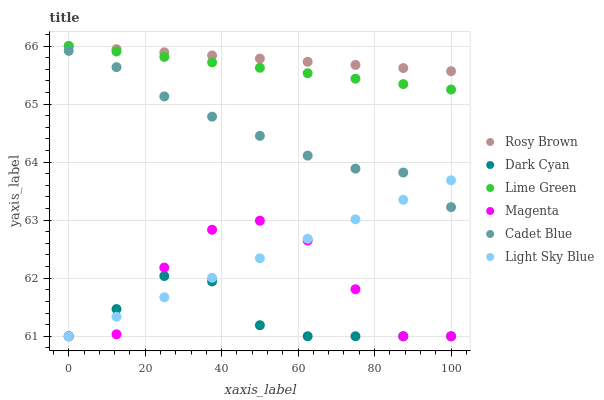Does Dark Cyan have the minimum area under the curve?
Answer yes or no. Yes. Does Rosy Brown have the maximum area under the curve?
Answer yes or no. Yes. Does Light Sky Blue have the minimum area under the curve?
Answer yes or no. No. Does Light Sky Blue have the maximum area under the curve?
Answer yes or no. No. Is Light Sky Blue the smoothest?
Answer yes or no. Yes. Is Magenta the roughest?
Answer yes or no. Yes. Is Rosy Brown the smoothest?
Answer yes or no. No. Is Rosy Brown the roughest?
Answer yes or no. No. Does Light Sky Blue have the lowest value?
Answer yes or no. Yes. Does Rosy Brown have the lowest value?
Answer yes or no. No. Does Lime Green have the highest value?
Answer yes or no. Yes. Does Light Sky Blue have the highest value?
Answer yes or no. No. Is Cadet Blue less than Rosy Brown?
Answer yes or no. Yes. Is Lime Green greater than Light Sky Blue?
Answer yes or no. Yes. Does Dark Cyan intersect Light Sky Blue?
Answer yes or no. Yes. Is Dark Cyan less than Light Sky Blue?
Answer yes or no. No. Is Dark Cyan greater than Light Sky Blue?
Answer yes or no. No. Does Cadet Blue intersect Rosy Brown?
Answer yes or no. No. 